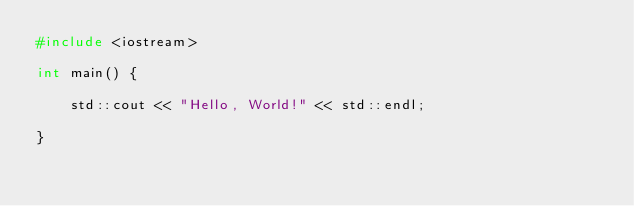<code> <loc_0><loc_0><loc_500><loc_500><_C++_>#include <iostream>

int main() {

    std::cout << "Hello, World!" << std::endl;

}
</code> 